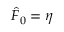Convert formula to latex. <formula><loc_0><loc_0><loc_500><loc_500>\hat { F } _ { 0 } = \eta</formula> 